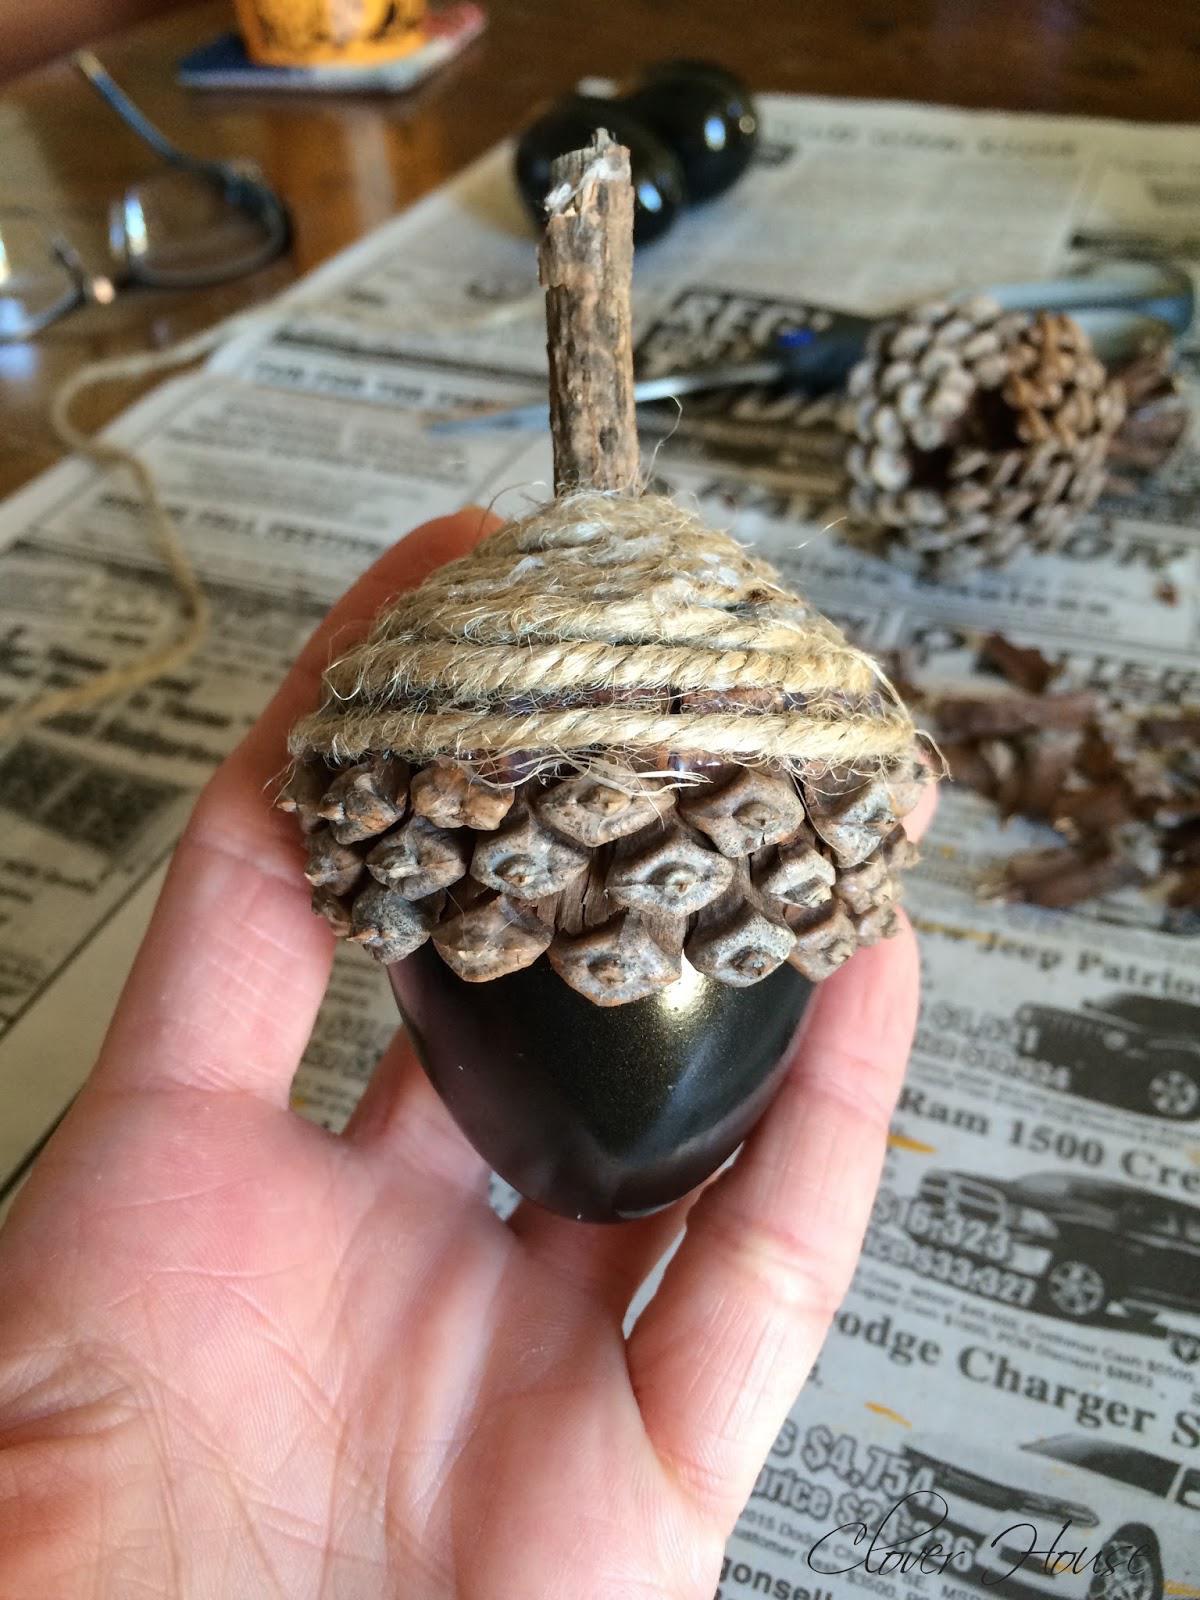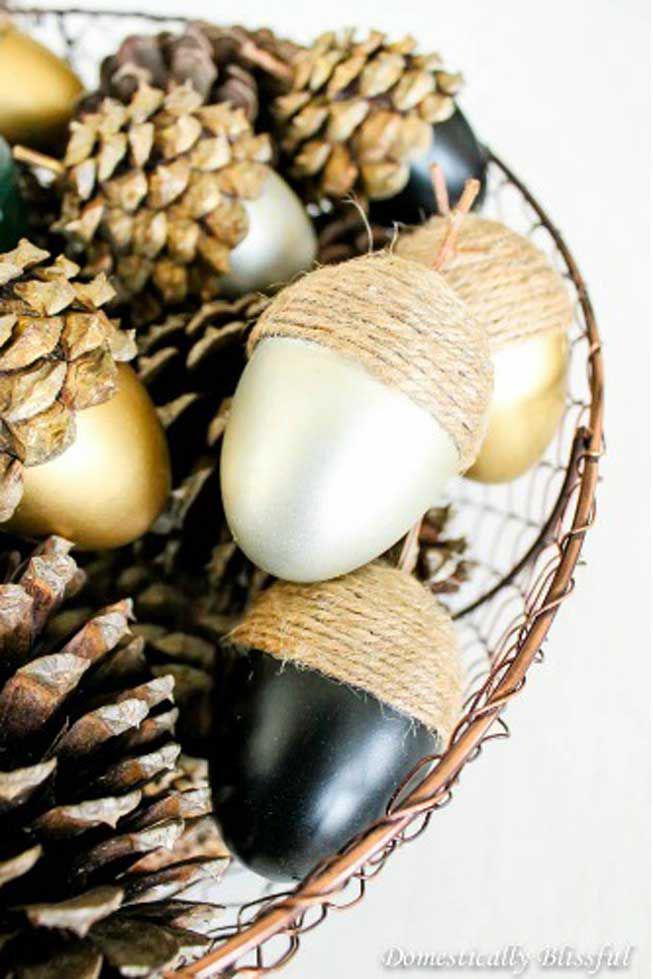The first image is the image on the left, the second image is the image on the right. Assess this claim about the two images: "The acorns in the left image are in a glass dish.". Correct or not? Answer yes or no. No. The first image is the image on the left, the second image is the image on the right. Analyze the images presented: Is the assertion "The left image shows two 'acorn eggs' - one gold and one brown - in an oblong scalloped glass bowl containing smooth stones." valid? Answer yes or no. No. 